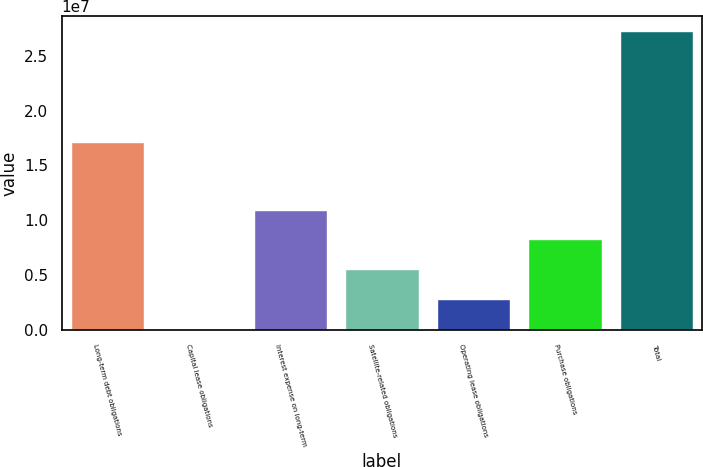Convert chart. <chart><loc_0><loc_0><loc_500><loc_500><bar_chart><fcel>Long-term debt obligations<fcel>Capital lease obligations<fcel>Interest expense on long-term<fcel>Satellite-related obligations<fcel>Operating lease obligations<fcel>Purchase obligations<fcel>Total<nl><fcel>1.71478e+07<fcel>136146<fcel>1.09838e+07<fcel>5.55998e+06<fcel>2.84806e+06<fcel>8.2719e+06<fcel>2.72553e+07<nl></chart> 